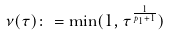Convert formula to latex. <formula><loc_0><loc_0><loc_500><loc_500>\nu ( \tau ) \colon = \min ( 1 , \tau ^ { \frac { 1 } { p _ { 1 } + 1 } } )</formula> 